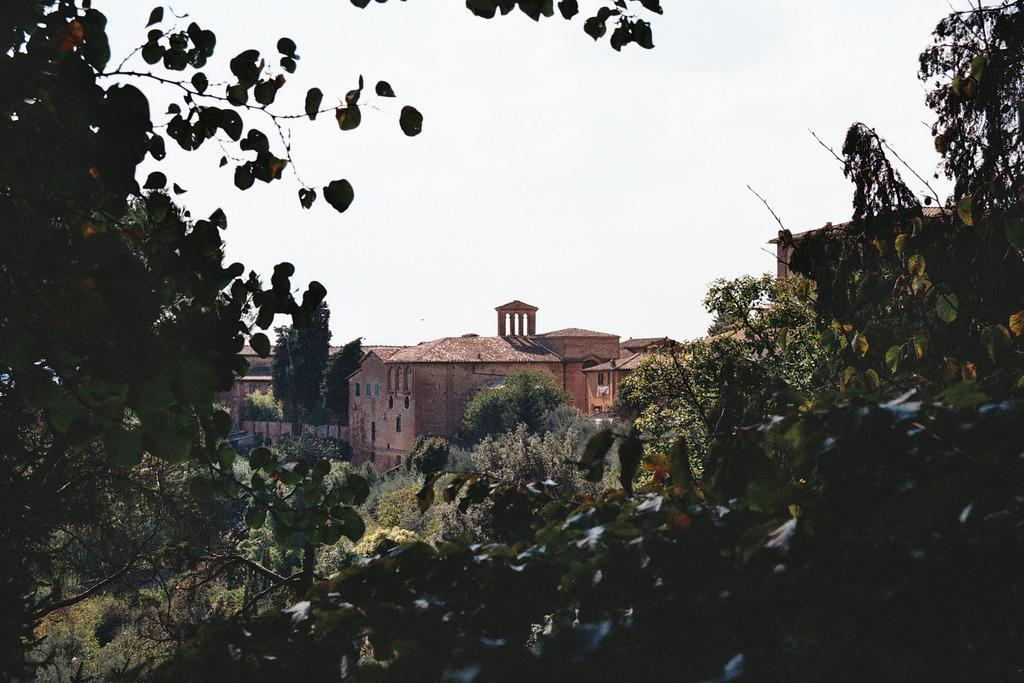What type of vegetation is present at the bottom of the image? There are trees at the bottom of the image. What type of structures can be seen in the background of the image? There are buildings in the background of the image. What is visible at the top of the image? The sky is visible at the top of the image. Where are the scissors located in the image? There are no scissors present in the image. What type of receipt can be seen in the image? There is no receipt present in the image. 